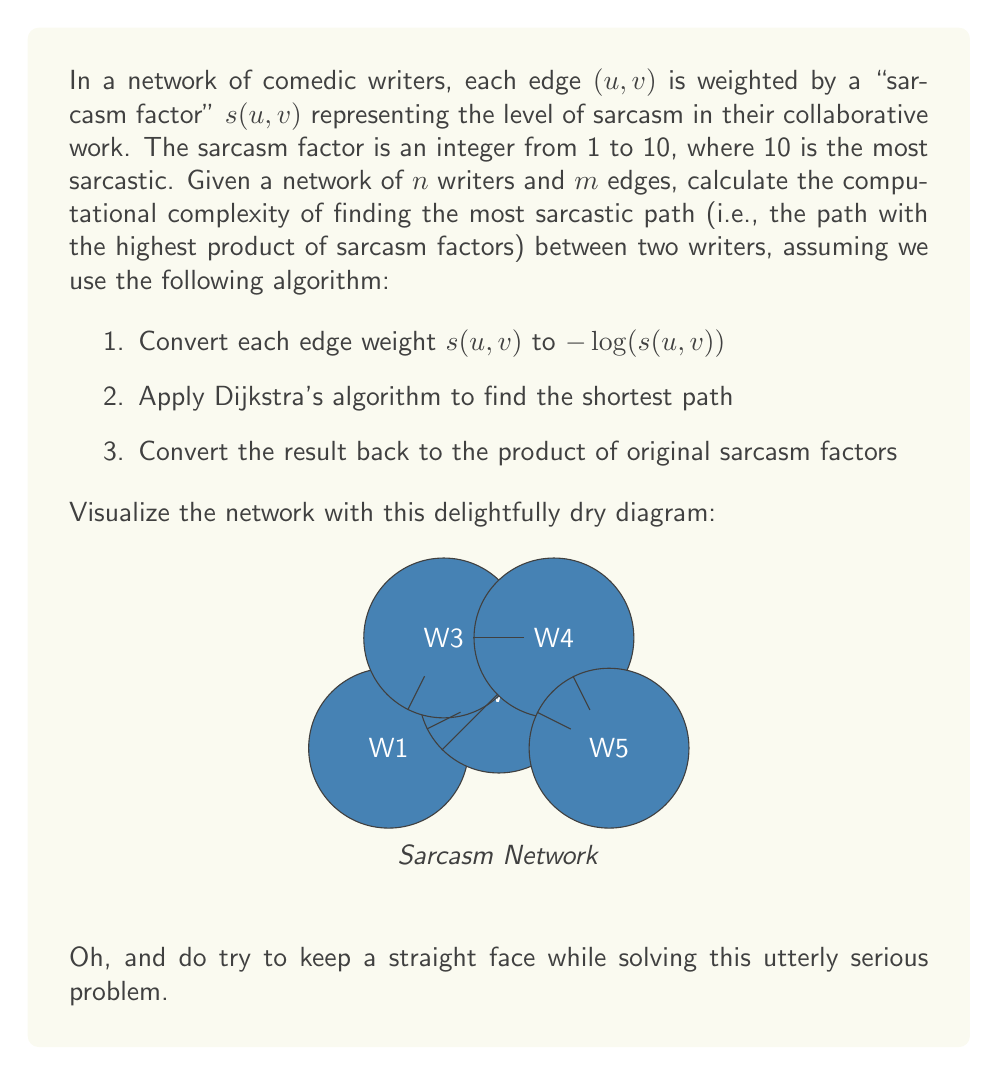Can you answer this question? Let's break down the complexity analysis step by step:

1. Converting edge weights:
   - Time complexity: $O(m)$ where $m$ is the number of edges
   - This step involves applying $-\log()$ to each edge weight

2. Applying Dijkstra's algorithm:
   - Time complexity: $O((n + m) \log n)$ using a binary heap implementation
   - Where $n$ is the number of nodes (writers) and $m$ is the number of edges

3. Converting the result back:
   - Time complexity: $O(n)$ in the worst case, as the path can have at most $n-1$ edges

Now, let's combine these steps:

$$T(n, m) = O(m) + O((n + m) \log n) + O(n)$$

Simplifying:
$$T(n, m) = O((n + m) \log n)$$

This is because:
- $O(m) \leq O((n + m) \log n)$ since $\log n \geq 1$ for $n \geq 2$
- $O(n) \leq O((n + m) \log n)$ for the same reason

Therefore, the overall computational complexity is dominated by Dijkstra's algorithm.

Ironically, finding the most sarcastic path turns out to be as complex as finding the least sarcastic one. Who would have thought?
Answer: $O((n + m) \log n)$ 